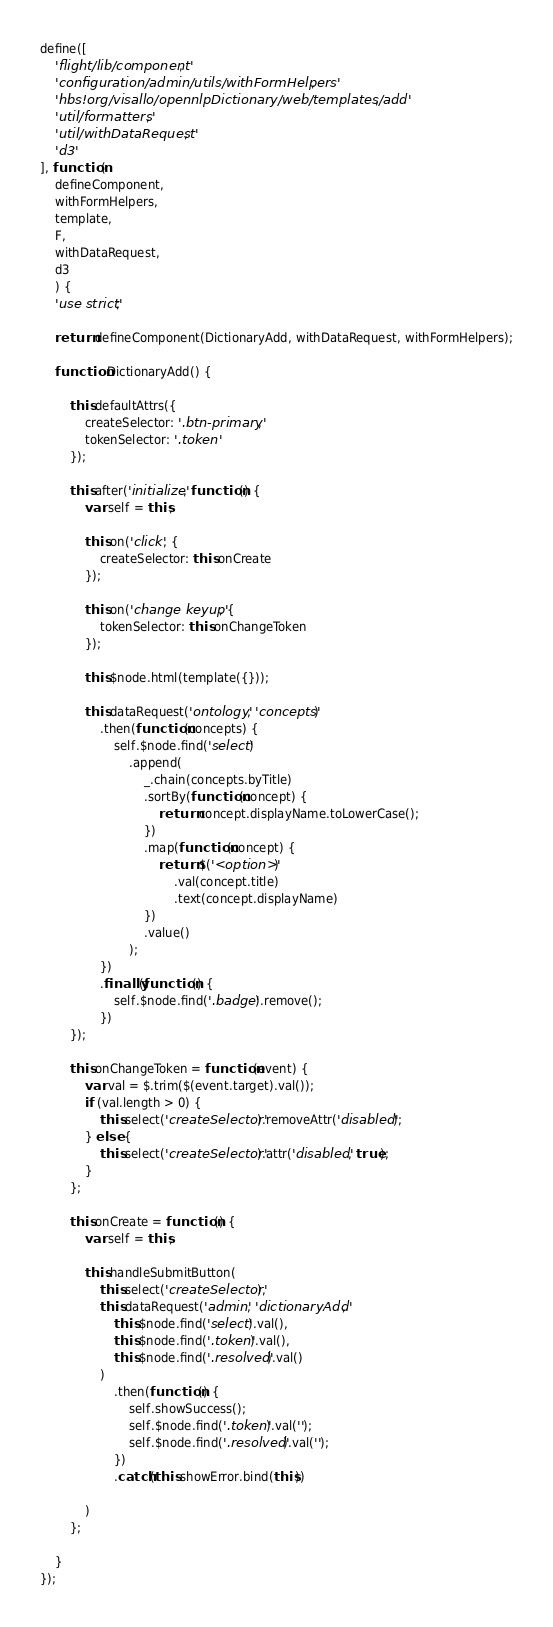Convert code to text. <code><loc_0><loc_0><loc_500><loc_500><_JavaScript_>define([
    'flight/lib/component',
    'configuration/admin/utils/withFormHelpers',
    'hbs!org/visallo/opennlpDictionary/web/templates/add',
    'util/formatters',
    'util/withDataRequest',
    'd3'
], function(
    defineComponent,
    withFormHelpers,
    template,
    F,
    withDataRequest,
    d3
    ) {
    'use strict';

    return defineComponent(DictionaryAdd, withDataRequest, withFormHelpers);

    function DictionaryAdd() {

        this.defaultAttrs({
            createSelector: '.btn-primary',
            tokenSelector: '.token'
        });

        this.after('initialize', function() {
            var self = this;

            this.on('click', {
                createSelector: this.onCreate
            });

            this.on('change keyup', {
                tokenSelector: this.onChangeToken
            });

            this.$node.html(template({}));

            this.dataRequest('ontology', 'concepts')
                .then(function(concepts) {
                    self.$node.find('select')
                        .append(
                            _.chain(concepts.byTitle)
                            .sortBy(function(concept) {
                                return concept.displayName.toLowerCase();
                            })
                            .map(function(concept) {
                                return $('<option>')
                                    .val(concept.title)
                                    .text(concept.displayName)
                            })
                            .value()
                        );
                })
                .finally(function() {
                    self.$node.find('.badge').remove();
                })
        });

        this.onChangeToken = function(event) {
            var val = $.trim($(event.target).val());
            if (val.length > 0) {
                this.select('createSelector').removeAttr('disabled');
            } else {
                this.select('createSelector').attr('disabled', true);
            }
        };

        this.onCreate = function() {
            var self = this;

            this.handleSubmitButton(
                this.select('createSelector'),
                this.dataRequest('admin', 'dictionaryAdd',
                    this.$node.find('select').val(),
                    this.$node.find('.token').val(),
                    this.$node.find('.resolved').val()
                )
                    .then(function() {
                        self.showSuccess();
                        self.$node.find('.token').val('');
                        self.$node.find('.resolved').val('');
                    })
                    .catch(this.showError.bind(this))

            )
        };

    }
});
</code> 